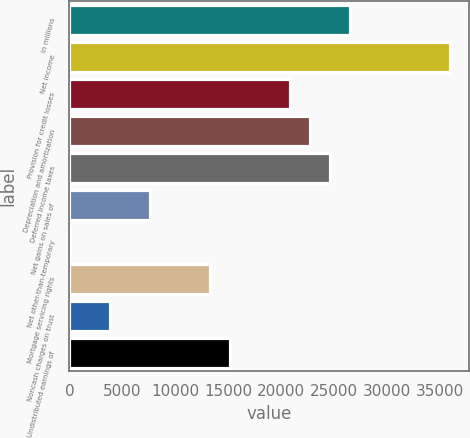<chart> <loc_0><loc_0><loc_500><loc_500><bar_chart><fcel>In millions<fcel>Net income<fcel>Provision for credit losses<fcel>Depreciation and amortization<fcel>Deferred income taxes<fcel>Net gains on sales of<fcel>Net other-than-temporary<fcel>Mortgage servicing rights<fcel>Noncash charges on trust<fcel>Undistributed earnings of<nl><fcel>26502.6<fcel>35962.1<fcel>20826.9<fcel>22718.8<fcel>24610.7<fcel>7583.6<fcel>16<fcel>13259.3<fcel>3799.8<fcel>15151.2<nl></chart> 